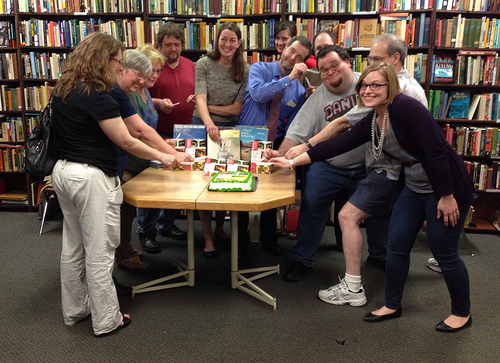<image>
Can you confirm if the shoe is on the woman? No. The shoe is not positioned on the woman. They may be near each other, but the shoe is not supported by or resting on top of the woman. Is there a girl on the man? No. The girl is not positioned on the man. They may be near each other, but the girl is not supported by or resting on top of the man. 